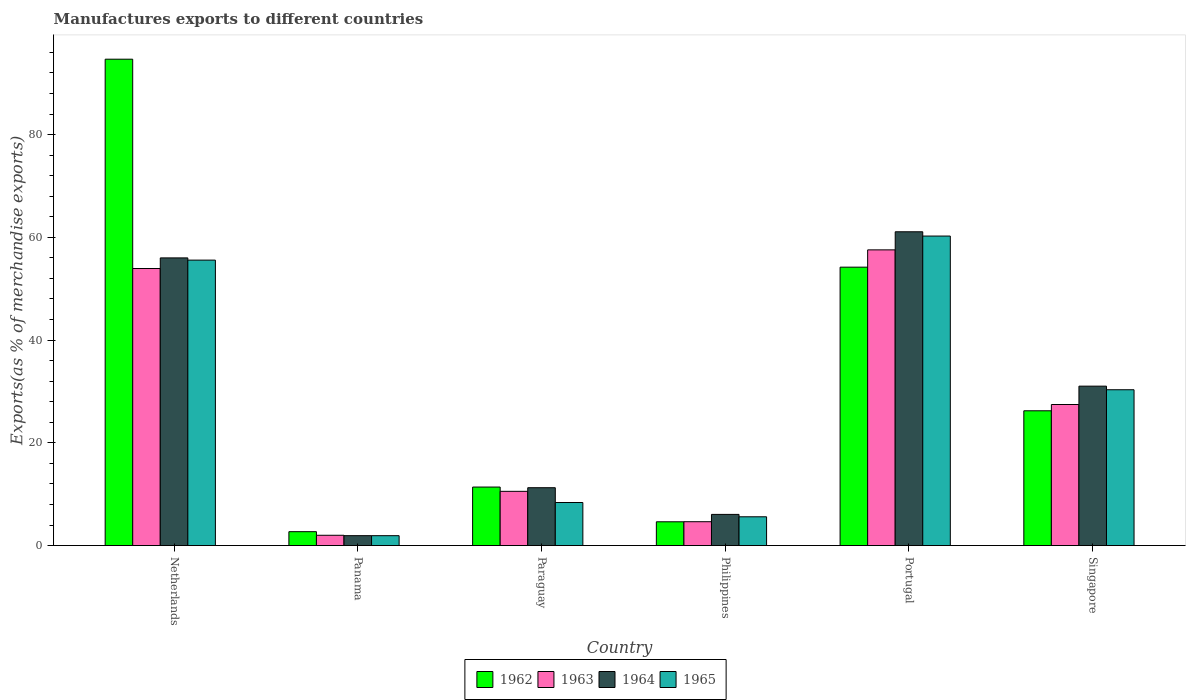How many groups of bars are there?
Provide a succinct answer. 6. Are the number of bars on each tick of the X-axis equal?
Your answer should be very brief. Yes. How many bars are there on the 6th tick from the left?
Offer a very short reply. 4. What is the label of the 4th group of bars from the left?
Ensure brevity in your answer.  Philippines. What is the percentage of exports to different countries in 1963 in Portugal?
Provide a succinct answer. 57.56. Across all countries, what is the maximum percentage of exports to different countries in 1962?
Make the answer very short. 94.68. Across all countries, what is the minimum percentage of exports to different countries in 1963?
Provide a short and direct response. 2. In which country was the percentage of exports to different countries in 1962 minimum?
Provide a short and direct response. Panama. What is the total percentage of exports to different countries in 1962 in the graph?
Provide a succinct answer. 193.83. What is the difference between the percentage of exports to different countries in 1963 in Netherlands and that in Singapore?
Offer a very short reply. 26.47. What is the difference between the percentage of exports to different countries in 1965 in Philippines and the percentage of exports to different countries in 1962 in Portugal?
Keep it short and to the point. -48.59. What is the average percentage of exports to different countries in 1962 per country?
Provide a succinct answer. 32.3. What is the difference between the percentage of exports to different countries of/in 1962 and percentage of exports to different countries of/in 1965 in Paraguay?
Your response must be concise. 3.01. In how many countries, is the percentage of exports to different countries in 1962 greater than 56 %?
Your response must be concise. 1. What is the ratio of the percentage of exports to different countries in 1964 in Paraguay to that in Singapore?
Your answer should be compact. 0.36. Is the percentage of exports to different countries in 1964 in Philippines less than that in Singapore?
Provide a short and direct response. Yes. What is the difference between the highest and the second highest percentage of exports to different countries in 1963?
Keep it short and to the point. 30.1. What is the difference between the highest and the lowest percentage of exports to different countries in 1963?
Provide a succinct answer. 55.56. In how many countries, is the percentage of exports to different countries in 1965 greater than the average percentage of exports to different countries in 1965 taken over all countries?
Give a very brief answer. 3. Is it the case that in every country, the sum of the percentage of exports to different countries in 1963 and percentage of exports to different countries in 1964 is greater than the sum of percentage of exports to different countries in 1962 and percentage of exports to different countries in 1965?
Make the answer very short. No. What does the 4th bar from the right in Paraguay represents?
Keep it short and to the point. 1962. How many bars are there?
Make the answer very short. 24. Are all the bars in the graph horizontal?
Keep it short and to the point. No. How many countries are there in the graph?
Provide a short and direct response. 6. Are the values on the major ticks of Y-axis written in scientific E-notation?
Make the answer very short. No. Does the graph contain any zero values?
Offer a terse response. No. Does the graph contain grids?
Your answer should be very brief. No. Where does the legend appear in the graph?
Provide a succinct answer. Bottom center. How many legend labels are there?
Your answer should be very brief. 4. How are the legend labels stacked?
Make the answer very short. Horizontal. What is the title of the graph?
Offer a terse response. Manufactures exports to different countries. Does "1967" appear as one of the legend labels in the graph?
Give a very brief answer. No. What is the label or title of the X-axis?
Make the answer very short. Country. What is the label or title of the Y-axis?
Offer a terse response. Exports(as % of merchandise exports). What is the Exports(as % of merchandise exports) in 1962 in Netherlands?
Your answer should be compact. 94.68. What is the Exports(as % of merchandise exports) of 1963 in Netherlands?
Your answer should be very brief. 53.93. What is the Exports(as % of merchandise exports) in 1964 in Netherlands?
Your response must be concise. 56. What is the Exports(as % of merchandise exports) of 1965 in Netherlands?
Make the answer very short. 55.57. What is the Exports(as % of merchandise exports) of 1962 in Panama?
Keep it short and to the point. 2.7. What is the Exports(as % of merchandise exports) in 1963 in Panama?
Ensure brevity in your answer.  2. What is the Exports(as % of merchandise exports) in 1964 in Panama?
Your response must be concise. 1.93. What is the Exports(as % of merchandise exports) in 1965 in Panama?
Keep it short and to the point. 1.92. What is the Exports(as % of merchandise exports) in 1962 in Paraguay?
Provide a short and direct response. 11.39. What is the Exports(as % of merchandise exports) of 1963 in Paraguay?
Your answer should be very brief. 10.55. What is the Exports(as % of merchandise exports) in 1964 in Paraguay?
Your answer should be compact. 11.26. What is the Exports(as % of merchandise exports) of 1965 in Paraguay?
Give a very brief answer. 8.38. What is the Exports(as % of merchandise exports) of 1962 in Philippines?
Provide a succinct answer. 4.63. What is the Exports(as % of merchandise exports) in 1963 in Philippines?
Your response must be concise. 4.64. What is the Exports(as % of merchandise exports) in 1964 in Philippines?
Provide a succinct answer. 6.07. What is the Exports(as % of merchandise exports) of 1965 in Philippines?
Give a very brief answer. 5.6. What is the Exports(as % of merchandise exports) of 1962 in Portugal?
Give a very brief answer. 54.19. What is the Exports(as % of merchandise exports) of 1963 in Portugal?
Your answer should be compact. 57.56. What is the Exports(as % of merchandise exports) of 1964 in Portugal?
Offer a very short reply. 61.08. What is the Exports(as % of merchandise exports) in 1965 in Portugal?
Your answer should be very brief. 60.25. What is the Exports(as % of merchandise exports) in 1962 in Singapore?
Your answer should be very brief. 26.24. What is the Exports(as % of merchandise exports) in 1963 in Singapore?
Your response must be concise. 27.46. What is the Exports(as % of merchandise exports) in 1964 in Singapore?
Your answer should be very brief. 31.03. What is the Exports(as % of merchandise exports) in 1965 in Singapore?
Provide a succinct answer. 30.33. Across all countries, what is the maximum Exports(as % of merchandise exports) in 1962?
Ensure brevity in your answer.  94.68. Across all countries, what is the maximum Exports(as % of merchandise exports) in 1963?
Provide a short and direct response. 57.56. Across all countries, what is the maximum Exports(as % of merchandise exports) of 1964?
Your answer should be very brief. 61.08. Across all countries, what is the maximum Exports(as % of merchandise exports) in 1965?
Provide a succinct answer. 60.25. Across all countries, what is the minimum Exports(as % of merchandise exports) in 1962?
Provide a succinct answer. 2.7. Across all countries, what is the minimum Exports(as % of merchandise exports) of 1963?
Provide a short and direct response. 2. Across all countries, what is the minimum Exports(as % of merchandise exports) of 1964?
Make the answer very short. 1.93. Across all countries, what is the minimum Exports(as % of merchandise exports) in 1965?
Offer a terse response. 1.92. What is the total Exports(as % of merchandise exports) in 1962 in the graph?
Your response must be concise. 193.83. What is the total Exports(as % of merchandise exports) in 1963 in the graph?
Keep it short and to the point. 156.16. What is the total Exports(as % of merchandise exports) in 1964 in the graph?
Offer a terse response. 167.37. What is the total Exports(as % of merchandise exports) of 1965 in the graph?
Ensure brevity in your answer.  162.06. What is the difference between the Exports(as % of merchandise exports) of 1962 in Netherlands and that in Panama?
Offer a terse response. 91.97. What is the difference between the Exports(as % of merchandise exports) in 1963 in Netherlands and that in Panama?
Provide a succinct answer. 51.93. What is the difference between the Exports(as % of merchandise exports) of 1964 in Netherlands and that in Panama?
Provide a short and direct response. 54.07. What is the difference between the Exports(as % of merchandise exports) in 1965 in Netherlands and that in Panama?
Your answer should be compact. 53.64. What is the difference between the Exports(as % of merchandise exports) in 1962 in Netherlands and that in Paraguay?
Make the answer very short. 83.29. What is the difference between the Exports(as % of merchandise exports) in 1963 in Netherlands and that in Paraguay?
Give a very brief answer. 43.38. What is the difference between the Exports(as % of merchandise exports) in 1964 in Netherlands and that in Paraguay?
Give a very brief answer. 44.74. What is the difference between the Exports(as % of merchandise exports) of 1965 in Netherlands and that in Paraguay?
Offer a very short reply. 47.19. What is the difference between the Exports(as % of merchandise exports) of 1962 in Netherlands and that in Philippines?
Offer a terse response. 90.05. What is the difference between the Exports(as % of merchandise exports) in 1963 in Netherlands and that in Philippines?
Make the answer very short. 49.29. What is the difference between the Exports(as % of merchandise exports) in 1964 in Netherlands and that in Philippines?
Offer a terse response. 49.93. What is the difference between the Exports(as % of merchandise exports) in 1965 in Netherlands and that in Philippines?
Ensure brevity in your answer.  49.96. What is the difference between the Exports(as % of merchandise exports) in 1962 in Netherlands and that in Portugal?
Offer a terse response. 40.48. What is the difference between the Exports(as % of merchandise exports) of 1963 in Netherlands and that in Portugal?
Your response must be concise. -3.63. What is the difference between the Exports(as % of merchandise exports) in 1964 in Netherlands and that in Portugal?
Your answer should be compact. -5.08. What is the difference between the Exports(as % of merchandise exports) of 1965 in Netherlands and that in Portugal?
Provide a succinct answer. -4.68. What is the difference between the Exports(as % of merchandise exports) of 1962 in Netherlands and that in Singapore?
Offer a terse response. 68.44. What is the difference between the Exports(as % of merchandise exports) of 1963 in Netherlands and that in Singapore?
Your answer should be compact. 26.47. What is the difference between the Exports(as % of merchandise exports) in 1964 in Netherlands and that in Singapore?
Your answer should be compact. 24.97. What is the difference between the Exports(as % of merchandise exports) of 1965 in Netherlands and that in Singapore?
Offer a very short reply. 25.23. What is the difference between the Exports(as % of merchandise exports) of 1962 in Panama and that in Paraguay?
Offer a very short reply. -8.69. What is the difference between the Exports(as % of merchandise exports) of 1963 in Panama and that in Paraguay?
Make the answer very short. -8.55. What is the difference between the Exports(as % of merchandise exports) in 1964 in Panama and that in Paraguay?
Offer a very short reply. -9.33. What is the difference between the Exports(as % of merchandise exports) of 1965 in Panama and that in Paraguay?
Offer a very short reply. -6.46. What is the difference between the Exports(as % of merchandise exports) in 1962 in Panama and that in Philippines?
Give a very brief answer. -1.92. What is the difference between the Exports(as % of merchandise exports) in 1963 in Panama and that in Philippines?
Your answer should be compact. -2.64. What is the difference between the Exports(as % of merchandise exports) in 1964 in Panama and that in Philippines?
Provide a short and direct response. -4.14. What is the difference between the Exports(as % of merchandise exports) of 1965 in Panama and that in Philippines?
Provide a succinct answer. -3.68. What is the difference between the Exports(as % of merchandise exports) of 1962 in Panama and that in Portugal?
Your response must be concise. -51.49. What is the difference between the Exports(as % of merchandise exports) in 1963 in Panama and that in Portugal?
Make the answer very short. -55.56. What is the difference between the Exports(as % of merchandise exports) in 1964 in Panama and that in Portugal?
Provide a short and direct response. -59.16. What is the difference between the Exports(as % of merchandise exports) in 1965 in Panama and that in Portugal?
Keep it short and to the point. -58.33. What is the difference between the Exports(as % of merchandise exports) of 1962 in Panama and that in Singapore?
Offer a very short reply. -23.53. What is the difference between the Exports(as % of merchandise exports) of 1963 in Panama and that in Singapore?
Offer a terse response. -25.46. What is the difference between the Exports(as % of merchandise exports) in 1964 in Panama and that in Singapore?
Make the answer very short. -29.1. What is the difference between the Exports(as % of merchandise exports) of 1965 in Panama and that in Singapore?
Your response must be concise. -28.41. What is the difference between the Exports(as % of merchandise exports) in 1962 in Paraguay and that in Philippines?
Keep it short and to the point. 6.76. What is the difference between the Exports(as % of merchandise exports) in 1963 in Paraguay and that in Philippines?
Keep it short and to the point. 5.91. What is the difference between the Exports(as % of merchandise exports) in 1964 in Paraguay and that in Philippines?
Offer a very short reply. 5.19. What is the difference between the Exports(as % of merchandise exports) in 1965 in Paraguay and that in Philippines?
Ensure brevity in your answer.  2.78. What is the difference between the Exports(as % of merchandise exports) of 1962 in Paraguay and that in Portugal?
Offer a terse response. -42.8. What is the difference between the Exports(as % of merchandise exports) in 1963 in Paraguay and that in Portugal?
Provide a succinct answer. -47.01. What is the difference between the Exports(as % of merchandise exports) in 1964 in Paraguay and that in Portugal?
Offer a very short reply. -49.82. What is the difference between the Exports(as % of merchandise exports) in 1965 in Paraguay and that in Portugal?
Give a very brief answer. -51.87. What is the difference between the Exports(as % of merchandise exports) of 1962 in Paraguay and that in Singapore?
Give a very brief answer. -14.85. What is the difference between the Exports(as % of merchandise exports) of 1963 in Paraguay and that in Singapore?
Keep it short and to the point. -16.91. What is the difference between the Exports(as % of merchandise exports) in 1964 in Paraguay and that in Singapore?
Your answer should be compact. -19.77. What is the difference between the Exports(as % of merchandise exports) of 1965 in Paraguay and that in Singapore?
Keep it short and to the point. -21.95. What is the difference between the Exports(as % of merchandise exports) of 1962 in Philippines and that in Portugal?
Your answer should be compact. -49.57. What is the difference between the Exports(as % of merchandise exports) of 1963 in Philippines and that in Portugal?
Offer a terse response. -52.92. What is the difference between the Exports(as % of merchandise exports) in 1964 in Philippines and that in Portugal?
Make the answer very short. -55.02. What is the difference between the Exports(as % of merchandise exports) of 1965 in Philippines and that in Portugal?
Your answer should be compact. -54.65. What is the difference between the Exports(as % of merchandise exports) of 1962 in Philippines and that in Singapore?
Give a very brief answer. -21.61. What is the difference between the Exports(as % of merchandise exports) in 1963 in Philippines and that in Singapore?
Offer a very short reply. -22.82. What is the difference between the Exports(as % of merchandise exports) of 1964 in Philippines and that in Singapore?
Your answer should be compact. -24.96. What is the difference between the Exports(as % of merchandise exports) of 1965 in Philippines and that in Singapore?
Offer a very short reply. -24.73. What is the difference between the Exports(as % of merchandise exports) in 1962 in Portugal and that in Singapore?
Your answer should be compact. 27.96. What is the difference between the Exports(as % of merchandise exports) of 1963 in Portugal and that in Singapore?
Offer a terse response. 30.1. What is the difference between the Exports(as % of merchandise exports) of 1964 in Portugal and that in Singapore?
Offer a terse response. 30.05. What is the difference between the Exports(as % of merchandise exports) in 1965 in Portugal and that in Singapore?
Give a very brief answer. 29.92. What is the difference between the Exports(as % of merchandise exports) in 1962 in Netherlands and the Exports(as % of merchandise exports) in 1963 in Panama?
Keep it short and to the point. 92.67. What is the difference between the Exports(as % of merchandise exports) of 1962 in Netherlands and the Exports(as % of merchandise exports) of 1964 in Panama?
Make the answer very short. 92.75. What is the difference between the Exports(as % of merchandise exports) in 1962 in Netherlands and the Exports(as % of merchandise exports) in 1965 in Panama?
Make the answer very short. 92.75. What is the difference between the Exports(as % of merchandise exports) of 1963 in Netherlands and the Exports(as % of merchandise exports) of 1964 in Panama?
Ensure brevity in your answer.  52. What is the difference between the Exports(as % of merchandise exports) of 1963 in Netherlands and the Exports(as % of merchandise exports) of 1965 in Panama?
Offer a terse response. 52.01. What is the difference between the Exports(as % of merchandise exports) in 1964 in Netherlands and the Exports(as % of merchandise exports) in 1965 in Panama?
Provide a succinct answer. 54.07. What is the difference between the Exports(as % of merchandise exports) of 1962 in Netherlands and the Exports(as % of merchandise exports) of 1963 in Paraguay?
Make the answer very short. 84.12. What is the difference between the Exports(as % of merchandise exports) of 1962 in Netherlands and the Exports(as % of merchandise exports) of 1964 in Paraguay?
Keep it short and to the point. 83.42. What is the difference between the Exports(as % of merchandise exports) of 1962 in Netherlands and the Exports(as % of merchandise exports) of 1965 in Paraguay?
Provide a succinct answer. 86.3. What is the difference between the Exports(as % of merchandise exports) of 1963 in Netherlands and the Exports(as % of merchandise exports) of 1964 in Paraguay?
Provide a short and direct response. 42.67. What is the difference between the Exports(as % of merchandise exports) in 1963 in Netherlands and the Exports(as % of merchandise exports) in 1965 in Paraguay?
Your answer should be very brief. 45.55. What is the difference between the Exports(as % of merchandise exports) in 1964 in Netherlands and the Exports(as % of merchandise exports) in 1965 in Paraguay?
Give a very brief answer. 47.62. What is the difference between the Exports(as % of merchandise exports) of 1962 in Netherlands and the Exports(as % of merchandise exports) of 1963 in Philippines?
Provide a succinct answer. 90.03. What is the difference between the Exports(as % of merchandise exports) of 1962 in Netherlands and the Exports(as % of merchandise exports) of 1964 in Philippines?
Make the answer very short. 88.61. What is the difference between the Exports(as % of merchandise exports) of 1962 in Netherlands and the Exports(as % of merchandise exports) of 1965 in Philippines?
Make the answer very short. 89.07. What is the difference between the Exports(as % of merchandise exports) in 1963 in Netherlands and the Exports(as % of merchandise exports) in 1964 in Philippines?
Offer a very short reply. 47.86. What is the difference between the Exports(as % of merchandise exports) of 1963 in Netherlands and the Exports(as % of merchandise exports) of 1965 in Philippines?
Your response must be concise. 48.33. What is the difference between the Exports(as % of merchandise exports) of 1964 in Netherlands and the Exports(as % of merchandise exports) of 1965 in Philippines?
Your answer should be very brief. 50.4. What is the difference between the Exports(as % of merchandise exports) in 1962 in Netherlands and the Exports(as % of merchandise exports) in 1963 in Portugal?
Give a very brief answer. 37.12. What is the difference between the Exports(as % of merchandise exports) in 1962 in Netherlands and the Exports(as % of merchandise exports) in 1964 in Portugal?
Offer a very short reply. 33.59. What is the difference between the Exports(as % of merchandise exports) of 1962 in Netherlands and the Exports(as % of merchandise exports) of 1965 in Portugal?
Offer a terse response. 34.43. What is the difference between the Exports(as % of merchandise exports) in 1963 in Netherlands and the Exports(as % of merchandise exports) in 1964 in Portugal?
Offer a terse response. -7.15. What is the difference between the Exports(as % of merchandise exports) of 1963 in Netherlands and the Exports(as % of merchandise exports) of 1965 in Portugal?
Your answer should be compact. -6.32. What is the difference between the Exports(as % of merchandise exports) of 1964 in Netherlands and the Exports(as % of merchandise exports) of 1965 in Portugal?
Provide a short and direct response. -4.25. What is the difference between the Exports(as % of merchandise exports) in 1962 in Netherlands and the Exports(as % of merchandise exports) in 1963 in Singapore?
Your answer should be compact. 67.22. What is the difference between the Exports(as % of merchandise exports) in 1962 in Netherlands and the Exports(as % of merchandise exports) in 1964 in Singapore?
Your response must be concise. 63.65. What is the difference between the Exports(as % of merchandise exports) in 1962 in Netherlands and the Exports(as % of merchandise exports) in 1965 in Singapore?
Offer a terse response. 64.34. What is the difference between the Exports(as % of merchandise exports) in 1963 in Netherlands and the Exports(as % of merchandise exports) in 1964 in Singapore?
Your response must be concise. 22.9. What is the difference between the Exports(as % of merchandise exports) of 1963 in Netherlands and the Exports(as % of merchandise exports) of 1965 in Singapore?
Your answer should be compact. 23.6. What is the difference between the Exports(as % of merchandise exports) of 1964 in Netherlands and the Exports(as % of merchandise exports) of 1965 in Singapore?
Provide a short and direct response. 25.67. What is the difference between the Exports(as % of merchandise exports) in 1962 in Panama and the Exports(as % of merchandise exports) in 1963 in Paraguay?
Make the answer very short. -7.85. What is the difference between the Exports(as % of merchandise exports) of 1962 in Panama and the Exports(as % of merchandise exports) of 1964 in Paraguay?
Offer a very short reply. -8.56. What is the difference between the Exports(as % of merchandise exports) of 1962 in Panama and the Exports(as % of merchandise exports) of 1965 in Paraguay?
Give a very brief answer. -5.68. What is the difference between the Exports(as % of merchandise exports) of 1963 in Panama and the Exports(as % of merchandise exports) of 1964 in Paraguay?
Provide a short and direct response. -9.26. What is the difference between the Exports(as % of merchandise exports) of 1963 in Panama and the Exports(as % of merchandise exports) of 1965 in Paraguay?
Provide a short and direct response. -6.38. What is the difference between the Exports(as % of merchandise exports) of 1964 in Panama and the Exports(as % of merchandise exports) of 1965 in Paraguay?
Offer a very short reply. -6.45. What is the difference between the Exports(as % of merchandise exports) in 1962 in Panama and the Exports(as % of merchandise exports) in 1963 in Philippines?
Give a very brief answer. -1.94. What is the difference between the Exports(as % of merchandise exports) in 1962 in Panama and the Exports(as % of merchandise exports) in 1964 in Philippines?
Your answer should be compact. -3.36. What is the difference between the Exports(as % of merchandise exports) of 1962 in Panama and the Exports(as % of merchandise exports) of 1965 in Philippines?
Ensure brevity in your answer.  -2.9. What is the difference between the Exports(as % of merchandise exports) in 1963 in Panama and the Exports(as % of merchandise exports) in 1964 in Philippines?
Your answer should be compact. -4.06. What is the difference between the Exports(as % of merchandise exports) in 1963 in Panama and the Exports(as % of merchandise exports) in 1965 in Philippines?
Ensure brevity in your answer.  -3.6. What is the difference between the Exports(as % of merchandise exports) in 1964 in Panama and the Exports(as % of merchandise exports) in 1965 in Philippines?
Keep it short and to the point. -3.68. What is the difference between the Exports(as % of merchandise exports) in 1962 in Panama and the Exports(as % of merchandise exports) in 1963 in Portugal?
Offer a terse response. -54.86. What is the difference between the Exports(as % of merchandise exports) in 1962 in Panama and the Exports(as % of merchandise exports) in 1964 in Portugal?
Make the answer very short. -58.38. What is the difference between the Exports(as % of merchandise exports) of 1962 in Panama and the Exports(as % of merchandise exports) of 1965 in Portugal?
Provide a succinct answer. -57.55. What is the difference between the Exports(as % of merchandise exports) of 1963 in Panama and the Exports(as % of merchandise exports) of 1964 in Portugal?
Provide a short and direct response. -59.08. What is the difference between the Exports(as % of merchandise exports) in 1963 in Panama and the Exports(as % of merchandise exports) in 1965 in Portugal?
Offer a very short reply. -58.25. What is the difference between the Exports(as % of merchandise exports) in 1964 in Panama and the Exports(as % of merchandise exports) in 1965 in Portugal?
Provide a succinct answer. -58.32. What is the difference between the Exports(as % of merchandise exports) of 1962 in Panama and the Exports(as % of merchandise exports) of 1963 in Singapore?
Your response must be concise. -24.76. What is the difference between the Exports(as % of merchandise exports) of 1962 in Panama and the Exports(as % of merchandise exports) of 1964 in Singapore?
Give a very brief answer. -28.33. What is the difference between the Exports(as % of merchandise exports) of 1962 in Panama and the Exports(as % of merchandise exports) of 1965 in Singapore?
Your response must be concise. -27.63. What is the difference between the Exports(as % of merchandise exports) in 1963 in Panama and the Exports(as % of merchandise exports) in 1964 in Singapore?
Ensure brevity in your answer.  -29.03. What is the difference between the Exports(as % of merchandise exports) in 1963 in Panama and the Exports(as % of merchandise exports) in 1965 in Singapore?
Ensure brevity in your answer.  -28.33. What is the difference between the Exports(as % of merchandise exports) in 1964 in Panama and the Exports(as % of merchandise exports) in 1965 in Singapore?
Make the answer very short. -28.41. What is the difference between the Exports(as % of merchandise exports) in 1962 in Paraguay and the Exports(as % of merchandise exports) in 1963 in Philippines?
Your answer should be compact. 6.75. What is the difference between the Exports(as % of merchandise exports) in 1962 in Paraguay and the Exports(as % of merchandise exports) in 1964 in Philippines?
Offer a terse response. 5.32. What is the difference between the Exports(as % of merchandise exports) in 1962 in Paraguay and the Exports(as % of merchandise exports) in 1965 in Philippines?
Keep it short and to the point. 5.79. What is the difference between the Exports(as % of merchandise exports) in 1963 in Paraguay and the Exports(as % of merchandise exports) in 1964 in Philippines?
Your answer should be very brief. 4.49. What is the difference between the Exports(as % of merchandise exports) of 1963 in Paraguay and the Exports(as % of merchandise exports) of 1965 in Philippines?
Your answer should be compact. 4.95. What is the difference between the Exports(as % of merchandise exports) in 1964 in Paraguay and the Exports(as % of merchandise exports) in 1965 in Philippines?
Make the answer very short. 5.66. What is the difference between the Exports(as % of merchandise exports) of 1962 in Paraguay and the Exports(as % of merchandise exports) of 1963 in Portugal?
Your answer should be very brief. -46.17. What is the difference between the Exports(as % of merchandise exports) in 1962 in Paraguay and the Exports(as % of merchandise exports) in 1964 in Portugal?
Offer a very short reply. -49.69. What is the difference between the Exports(as % of merchandise exports) in 1962 in Paraguay and the Exports(as % of merchandise exports) in 1965 in Portugal?
Ensure brevity in your answer.  -48.86. What is the difference between the Exports(as % of merchandise exports) of 1963 in Paraguay and the Exports(as % of merchandise exports) of 1964 in Portugal?
Keep it short and to the point. -50.53. What is the difference between the Exports(as % of merchandise exports) of 1963 in Paraguay and the Exports(as % of merchandise exports) of 1965 in Portugal?
Your answer should be very brief. -49.7. What is the difference between the Exports(as % of merchandise exports) in 1964 in Paraguay and the Exports(as % of merchandise exports) in 1965 in Portugal?
Your answer should be very brief. -48.99. What is the difference between the Exports(as % of merchandise exports) of 1962 in Paraguay and the Exports(as % of merchandise exports) of 1963 in Singapore?
Give a very brief answer. -16.07. What is the difference between the Exports(as % of merchandise exports) in 1962 in Paraguay and the Exports(as % of merchandise exports) in 1964 in Singapore?
Provide a short and direct response. -19.64. What is the difference between the Exports(as % of merchandise exports) in 1962 in Paraguay and the Exports(as % of merchandise exports) in 1965 in Singapore?
Your answer should be very brief. -18.94. What is the difference between the Exports(as % of merchandise exports) of 1963 in Paraguay and the Exports(as % of merchandise exports) of 1964 in Singapore?
Provide a succinct answer. -20.48. What is the difference between the Exports(as % of merchandise exports) in 1963 in Paraguay and the Exports(as % of merchandise exports) in 1965 in Singapore?
Your answer should be compact. -19.78. What is the difference between the Exports(as % of merchandise exports) of 1964 in Paraguay and the Exports(as % of merchandise exports) of 1965 in Singapore?
Provide a short and direct response. -19.07. What is the difference between the Exports(as % of merchandise exports) of 1962 in Philippines and the Exports(as % of merchandise exports) of 1963 in Portugal?
Provide a short and direct response. -52.93. What is the difference between the Exports(as % of merchandise exports) of 1962 in Philippines and the Exports(as % of merchandise exports) of 1964 in Portugal?
Provide a succinct answer. -56.46. What is the difference between the Exports(as % of merchandise exports) in 1962 in Philippines and the Exports(as % of merchandise exports) in 1965 in Portugal?
Ensure brevity in your answer.  -55.62. What is the difference between the Exports(as % of merchandise exports) in 1963 in Philippines and the Exports(as % of merchandise exports) in 1964 in Portugal?
Make the answer very short. -56.44. What is the difference between the Exports(as % of merchandise exports) of 1963 in Philippines and the Exports(as % of merchandise exports) of 1965 in Portugal?
Your response must be concise. -55.61. What is the difference between the Exports(as % of merchandise exports) in 1964 in Philippines and the Exports(as % of merchandise exports) in 1965 in Portugal?
Make the answer very short. -54.18. What is the difference between the Exports(as % of merchandise exports) in 1962 in Philippines and the Exports(as % of merchandise exports) in 1963 in Singapore?
Your answer should be compact. -22.83. What is the difference between the Exports(as % of merchandise exports) in 1962 in Philippines and the Exports(as % of merchandise exports) in 1964 in Singapore?
Provide a short and direct response. -26.4. What is the difference between the Exports(as % of merchandise exports) in 1962 in Philippines and the Exports(as % of merchandise exports) in 1965 in Singapore?
Your response must be concise. -25.7. What is the difference between the Exports(as % of merchandise exports) in 1963 in Philippines and the Exports(as % of merchandise exports) in 1964 in Singapore?
Provide a short and direct response. -26.39. What is the difference between the Exports(as % of merchandise exports) of 1963 in Philippines and the Exports(as % of merchandise exports) of 1965 in Singapore?
Your answer should be very brief. -25.69. What is the difference between the Exports(as % of merchandise exports) of 1964 in Philippines and the Exports(as % of merchandise exports) of 1965 in Singapore?
Keep it short and to the point. -24.27. What is the difference between the Exports(as % of merchandise exports) in 1962 in Portugal and the Exports(as % of merchandise exports) in 1963 in Singapore?
Your answer should be very brief. 26.73. What is the difference between the Exports(as % of merchandise exports) of 1962 in Portugal and the Exports(as % of merchandise exports) of 1964 in Singapore?
Provide a succinct answer. 23.16. What is the difference between the Exports(as % of merchandise exports) in 1962 in Portugal and the Exports(as % of merchandise exports) in 1965 in Singapore?
Your response must be concise. 23.86. What is the difference between the Exports(as % of merchandise exports) of 1963 in Portugal and the Exports(as % of merchandise exports) of 1964 in Singapore?
Keep it short and to the point. 26.53. What is the difference between the Exports(as % of merchandise exports) of 1963 in Portugal and the Exports(as % of merchandise exports) of 1965 in Singapore?
Make the answer very short. 27.23. What is the difference between the Exports(as % of merchandise exports) of 1964 in Portugal and the Exports(as % of merchandise exports) of 1965 in Singapore?
Your answer should be very brief. 30.75. What is the average Exports(as % of merchandise exports) in 1962 per country?
Your answer should be compact. 32.3. What is the average Exports(as % of merchandise exports) in 1963 per country?
Your response must be concise. 26.03. What is the average Exports(as % of merchandise exports) of 1964 per country?
Offer a terse response. 27.89. What is the average Exports(as % of merchandise exports) in 1965 per country?
Give a very brief answer. 27.01. What is the difference between the Exports(as % of merchandise exports) of 1962 and Exports(as % of merchandise exports) of 1963 in Netherlands?
Your response must be concise. 40.75. What is the difference between the Exports(as % of merchandise exports) of 1962 and Exports(as % of merchandise exports) of 1964 in Netherlands?
Make the answer very short. 38.68. What is the difference between the Exports(as % of merchandise exports) of 1962 and Exports(as % of merchandise exports) of 1965 in Netherlands?
Your answer should be compact. 39.11. What is the difference between the Exports(as % of merchandise exports) in 1963 and Exports(as % of merchandise exports) in 1964 in Netherlands?
Your response must be concise. -2.07. What is the difference between the Exports(as % of merchandise exports) of 1963 and Exports(as % of merchandise exports) of 1965 in Netherlands?
Your response must be concise. -1.64. What is the difference between the Exports(as % of merchandise exports) of 1964 and Exports(as % of merchandise exports) of 1965 in Netherlands?
Your answer should be very brief. 0.43. What is the difference between the Exports(as % of merchandise exports) in 1962 and Exports(as % of merchandise exports) in 1963 in Panama?
Offer a very short reply. 0.7. What is the difference between the Exports(as % of merchandise exports) of 1962 and Exports(as % of merchandise exports) of 1964 in Panama?
Offer a very short reply. 0.78. What is the difference between the Exports(as % of merchandise exports) of 1962 and Exports(as % of merchandise exports) of 1965 in Panama?
Offer a very short reply. 0.78. What is the difference between the Exports(as % of merchandise exports) in 1963 and Exports(as % of merchandise exports) in 1964 in Panama?
Make the answer very short. 0.08. What is the difference between the Exports(as % of merchandise exports) of 1963 and Exports(as % of merchandise exports) of 1965 in Panama?
Offer a very short reply. 0.08. What is the difference between the Exports(as % of merchandise exports) of 1964 and Exports(as % of merchandise exports) of 1965 in Panama?
Ensure brevity in your answer.  0. What is the difference between the Exports(as % of merchandise exports) of 1962 and Exports(as % of merchandise exports) of 1963 in Paraguay?
Make the answer very short. 0.83. What is the difference between the Exports(as % of merchandise exports) in 1962 and Exports(as % of merchandise exports) in 1964 in Paraguay?
Keep it short and to the point. 0.13. What is the difference between the Exports(as % of merchandise exports) of 1962 and Exports(as % of merchandise exports) of 1965 in Paraguay?
Keep it short and to the point. 3.01. What is the difference between the Exports(as % of merchandise exports) of 1963 and Exports(as % of merchandise exports) of 1964 in Paraguay?
Offer a terse response. -0.71. What is the difference between the Exports(as % of merchandise exports) of 1963 and Exports(as % of merchandise exports) of 1965 in Paraguay?
Offer a terse response. 2.17. What is the difference between the Exports(as % of merchandise exports) of 1964 and Exports(as % of merchandise exports) of 1965 in Paraguay?
Provide a short and direct response. 2.88. What is the difference between the Exports(as % of merchandise exports) in 1962 and Exports(as % of merchandise exports) in 1963 in Philippines?
Provide a succinct answer. -0.02. What is the difference between the Exports(as % of merchandise exports) of 1962 and Exports(as % of merchandise exports) of 1964 in Philippines?
Offer a terse response. -1.44. What is the difference between the Exports(as % of merchandise exports) in 1962 and Exports(as % of merchandise exports) in 1965 in Philippines?
Your answer should be compact. -0.98. What is the difference between the Exports(as % of merchandise exports) in 1963 and Exports(as % of merchandise exports) in 1964 in Philippines?
Provide a short and direct response. -1.42. What is the difference between the Exports(as % of merchandise exports) of 1963 and Exports(as % of merchandise exports) of 1965 in Philippines?
Offer a terse response. -0.96. What is the difference between the Exports(as % of merchandise exports) in 1964 and Exports(as % of merchandise exports) in 1965 in Philippines?
Make the answer very short. 0.46. What is the difference between the Exports(as % of merchandise exports) of 1962 and Exports(as % of merchandise exports) of 1963 in Portugal?
Offer a very short reply. -3.37. What is the difference between the Exports(as % of merchandise exports) in 1962 and Exports(as % of merchandise exports) in 1964 in Portugal?
Give a very brief answer. -6.89. What is the difference between the Exports(as % of merchandise exports) in 1962 and Exports(as % of merchandise exports) in 1965 in Portugal?
Offer a very short reply. -6.06. What is the difference between the Exports(as % of merchandise exports) in 1963 and Exports(as % of merchandise exports) in 1964 in Portugal?
Offer a terse response. -3.52. What is the difference between the Exports(as % of merchandise exports) in 1963 and Exports(as % of merchandise exports) in 1965 in Portugal?
Your answer should be very brief. -2.69. What is the difference between the Exports(as % of merchandise exports) in 1964 and Exports(as % of merchandise exports) in 1965 in Portugal?
Make the answer very short. 0.83. What is the difference between the Exports(as % of merchandise exports) of 1962 and Exports(as % of merchandise exports) of 1963 in Singapore?
Give a very brief answer. -1.22. What is the difference between the Exports(as % of merchandise exports) in 1962 and Exports(as % of merchandise exports) in 1964 in Singapore?
Provide a short and direct response. -4.79. What is the difference between the Exports(as % of merchandise exports) in 1962 and Exports(as % of merchandise exports) in 1965 in Singapore?
Offer a very short reply. -4.1. What is the difference between the Exports(as % of merchandise exports) in 1963 and Exports(as % of merchandise exports) in 1964 in Singapore?
Offer a very short reply. -3.57. What is the difference between the Exports(as % of merchandise exports) of 1963 and Exports(as % of merchandise exports) of 1965 in Singapore?
Keep it short and to the point. -2.87. What is the difference between the Exports(as % of merchandise exports) of 1964 and Exports(as % of merchandise exports) of 1965 in Singapore?
Offer a terse response. 0.7. What is the ratio of the Exports(as % of merchandise exports) of 1962 in Netherlands to that in Panama?
Provide a short and direct response. 35.02. What is the ratio of the Exports(as % of merchandise exports) in 1963 in Netherlands to that in Panama?
Your answer should be compact. 26.91. What is the ratio of the Exports(as % of merchandise exports) of 1964 in Netherlands to that in Panama?
Make the answer very short. 29.06. What is the ratio of the Exports(as % of merchandise exports) of 1965 in Netherlands to that in Panama?
Offer a terse response. 28.9. What is the ratio of the Exports(as % of merchandise exports) of 1962 in Netherlands to that in Paraguay?
Provide a succinct answer. 8.31. What is the ratio of the Exports(as % of merchandise exports) of 1963 in Netherlands to that in Paraguay?
Keep it short and to the point. 5.11. What is the ratio of the Exports(as % of merchandise exports) in 1964 in Netherlands to that in Paraguay?
Your answer should be very brief. 4.97. What is the ratio of the Exports(as % of merchandise exports) in 1965 in Netherlands to that in Paraguay?
Give a very brief answer. 6.63. What is the ratio of the Exports(as % of merchandise exports) in 1962 in Netherlands to that in Philippines?
Offer a terse response. 20.46. What is the ratio of the Exports(as % of merchandise exports) in 1963 in Netherlands to that in Philippines?
Provide a succinct answer. 11.61. What is the ratio of the Exports(as % of merchandise exports) in 1964 in Netherlands to that in Philippines?
Give a very brief answer. 9.23. What is the ratio of the Exports(as % of merchandise exports) of 1965 in Netherlands to that in Philippines?
Ensure brevity in your answer.  9.92. What is the ratio of the Exports(as % of merchandise exports) in 1962 in Netherlands to that in Portugal?
Give a very brief answer. 1.75. What is the ratio of the Exports(as % of merchandise exports) of 1963 in Netherlands to that in Portugal?
Give a very brief answer. 0.94. What is the ratio of the Exports(as % of merchandise exports) in 1964 in Netherlands to that in Portugal?
Keep it short and to the point. 0.92. What is the ratio of the Exports(as % of merchandise exports) in 1965 in Netherlands to that in Portugal?
Keep it short and to the point. 0.92. What is the ratio of the Exports(as % of merchandise exports) of 1962 in Netherlands to that in Singapore?
Your answer should be compact. 3.61. What is the ratio of the Exports(as % of merchandise exports) in 1963 in Netherlands to that in Singapore?
Provide a succinct answer. 1.96. What is the ratio of the Exports(as % of merchandise exports) in 1964 in Netherlands to that in Singapore?
Ensure brevity in your answer.  1.8. What is the ratio of the Exports(as % of merchandise exports) in 1965 in Netherlands to that in Singapore?
Ensure brevity in your answer.  1.83. What is the ratio of the Exports(as % of merchandise exports) of 1962 in Panama to that in Paraguay?
Ensure brevity in your answer.  0.24. What is the ratio of the Exports(as % of merchandise exports) of 1963 in Panama to that in Paraguay?
Make the answer very short. 0.19. What is the ratio of the Exports(as % of merchandise exports) in 1964 in Panama to that in Paraguay?
Keep it short and to the point. 0.17. What is the ratio of the Exports(as % of merchandise exports) of 1965 in Panama to that in Paraguay?
Provide a succinct answer. 0.23. What is the ratio of the Exports(as % of merchandise exports) of 1962 in Panama to that in Philippines?
Provide a succinct answer. 0.58. What is the ratio of the Exports(as % of merchandise exports) in 1963 in Panama to that in Philippines?
Give a very brief answer. 0.43. What is the ratio of the Exports(as % of merchandise exports) in 1964 in Panama to that in Philippines?
Your answer should be compact. 0.32. What is the ratio of the Exports(as % of merchandise exports) in 1965 in Panama to that in Philippines?
Provide a succinct answer. 0.34. What is the ratio of the Exports(as % of merchandise exports) of 1962 in Panama to that in Portugal?
Give a very brief answer. 0.05. What is the ratio of the Exports(as % of merchandise exports) in 1963 in Panama to that in Portugal?
Give a very brief answer. 0.03. What is the ratio of the Exports(as % of merchandise exports) of 1964 in Panama to that in Portugal?
Offer a very short reply. 0.03. What is the ratio of the Exports(as % of merchandise exports) of 1965 in Panama to that in Portugal?
Keep it short and to the point. 0.03. What is the ratio of the Exports(as % of merchandise exports) in 1962 in Panama to that in Singapore?
Offer a very short reply. 0.1. What is the ratio of the Exports(as % of merchandise exports) of 1963 in Panama to that in Singapore?
Give a very brief answer. 0.07. What is the ratio of the Exports(as % of merchandise exports) of 1964 in Panama to that in Singapore?
Keep it short and to the point. 0.06. What is the ratio of the Exports(as % of merchandise exports) in 1965 in Panama to that in Singapore?
Give a very brief answer. 0.06. What is the ratio of the Exports(as % of merchandise exports) of 1962 in Paraguay to that in Philippines?
Your response must be concise. 2.46. What is the ratio of the Exports(as % of merchandise exports) in 1963 in Paraguay to that in Philippines?
Keep it short and to the point. 2.27. What is the ratio of the Exports(as % of merchandise exports) of 1964 in Paraguay to that in Philippines?
Give a very brief answer. 1.86. What is the ratio of the Exports(as % of merchandise exports) of 1965 in Paraguay to that in Philippines?
Give a very brief answer. 1.5. What is the ratio of the Exports(as % of merchandise exports) in 1962 in Paraguay to that in Portugal?
Your response must be concise. 0.21. What is the ratio of the Exports(as % of merchandise exports) of 1963 in Paraguay to that in Portugal?
Offer a very short reply. 0.18. What is the ratio of the Exports(as % of merchandise exports) of 1964 in Paraguay to that in Portugal?
Ensure brevity in your answer.  0.18. What is the ratio of the Exports(as % of merchandise exports) in 1965 in Paraguay to that in Portugal?
Provide a short and direct response. 0.14. What is the ratio of the Exports(as % of merchandise exports) in 1962 in Paraguay to that in Singapore?
Give a very brief answer. 0.43. What is the ratio of the Exports(as % of merchandise exports) in 1963 in Paraguay to that in Singapore?
Offer a very short reply. 0.38. What is the ratio of the Exports(as % of merchandise exports) in 1964 in Paraguay to that in Singapore?
Your answer should be compact. 0.36. What is the ratio of the Exports(as % of merchandise exports) in 1965 in Paraguay to that in Singapore?
Your answer should be very brief. 0.28. What is the ratio of the Exports(as % of merchandise exports) in 1962 in Philippines to that in Portugal?
Provide a short and direct response. 0.09. What is the ratio of the Exports(as % of merchandise exports) of 1963 in Philippines to that in Portugal?
Provide a succinct answer. 0.08. What is the ratio of the Exports(as % of merchandise exports) in 1964 in Philippines to that in Portugal?
Offer a terse response. 0.1. What is the ratio of the Exports(as % of merchandise exports) in 1965 in Philippines to that in Portugal?
Give a very brief answer. 0.09. What is the ratio of the Exports(as % of merchandise exports) in 1962 in Philippines to that in Singapore?
Your answer should be very brief. 0.18. What is the ratio of the Exports(as % of merchandise exports) of 1963 in Philippines to that in Singapore?
Keep it short and to the point. 0.17. What is the ratio of the Exports(as % of merchandise exports) of 1964 in Philippines to that in Singapore?
Offer a terse response. 0.2. What is the ratio of the Exports(as % of merchandise exports) in 1965 in Philippines to that in Singapore?
Your answer should be compact. 0.18. What is the ratio of the Exports(as % of merchandise exports) of 1962 in Portugal to that in Singapore?
Your answer should be compact. 2.07. What is the ratio of the Exports(as % of merchandise exports) of 1963 in Portugal to that in Singapore?
Your answer should be compact. 2.1. What is the ratio of the Exports(as % of merchandise exports) in 1964 in Portugal to that in Singapore?
Keep it short and to the point. 1.97. What is the ratio of the Exports(as % of merchandise exports) in 1965 in Portugal to that in Singapore?
Make the answer very short. 1.99. What is the difference between the highest and the second highest Exports(as % of merchandise exports) of 1962?
Give a very brief answer. 40.48. What is the difference between the highest and the second highest Exports(as % of merchandise exports) of 1963?
Offer a terse response. 3.63. What is the difference between the highest and the second highest Exports(as % of merchandise exports) in 1964?
Provide a succinct answer. 5.08. What is the difference between the highest and the second highest Exports(as % of merchandise exports) of 1965?
Ensure brevity in your answer.  4.68. What is the difference between the highest and the lowest Exports(as % of merchandise exports) in 1962?
Your response must be concise. 91.97. What is the difference between the highest and the lowest Exports(as % of merchandise exports) of 1963?
Provide a succinct answer. 55.56. What is the difference between the highest and the lowest Exports(as % of merchandise exports) in 1964?
Offer a very short reply. 59.16. What is the difference between the highest and the lowest Exports(as % of merchandise exports) of 1965?
Keep it short and to the point. 58.33. 